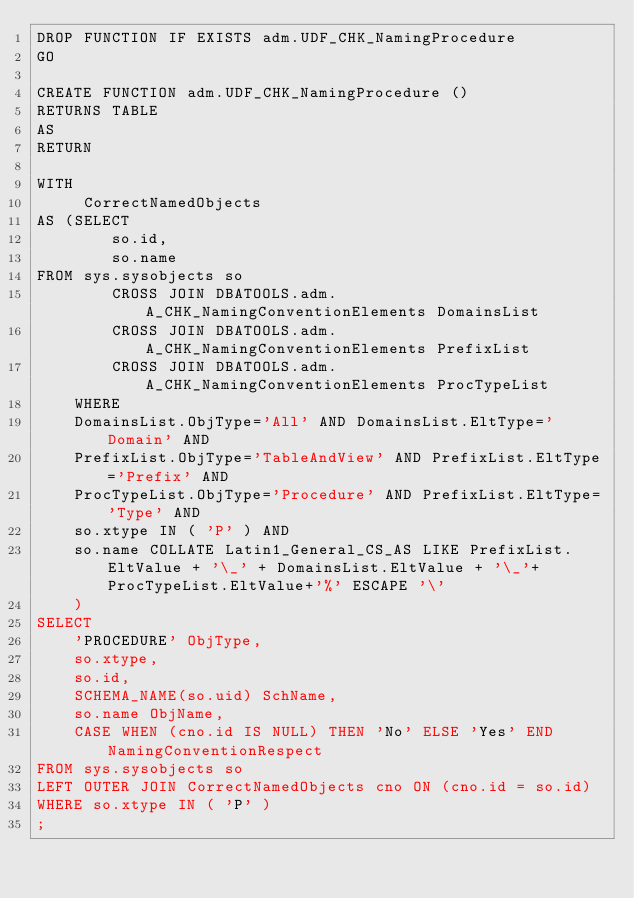Convert code to text. <code><loc_0><loc_0><loc_500><loc_500><_SQL_>DROP FUNCTION IF EXISTS adm.UDF_CHK_NamingProcedure
GO

CREATE FUNCTION adm.UDF_CHK_NamingProcedure ()
RETURNS TABLE
AS
RETURN

WITH 
     CorrectNamedObjects
AS (SELECT 
		so.id,
		so.name
FROM sys.sysobjects so
        CROSS JOIN DBATOOLS.adm.A_CHK_NamingConventionElements DomainsList
        CROSS JOIN DBATOOLS.adm.A_CHK_NamingConventionElements PrefixList
		CROSS JOIN DBATOOLS.adm.A_CHK_NamingConventionElements ProcTypeList
    WHERE 
	DomainsList.ObjType='All' AND DomainsList.EltType='Domain' AND
	PrefixList.ObjType='TableAndView' AND PrefixList.EltType='Prefix' AND
	ProcTypeList.ObjType='Procedure' AND PrefixList.EltType='Type' AND
	so.xtype IN ( 'P' ) AND
	so.name COLLATE Latin1_General_CS_AS LIKE PrefixList.EltValue + '\_' + DomainsList.EltValue + '\_'+ ProcTypeList.EltValue+'%' ESCAPE '\'
	)
SELECT 
	'PROCEDURE' ObjType,
	so.xtype,
	so.id, 
	SCHEMA_NAME(so.uid) SchName,
	so.name ObjName, 
	CASE WHEN (cno.id IS NULL) THEN 'No' ELSE 'Yes' END NamingConventionRespect
FROM sys.sysobjects so
LEFT OUTER JOIN CorrectNamedObjects cno ON (cno.id = so.id)
WHERE so.xtype IN ( 'P' )
;</code> 